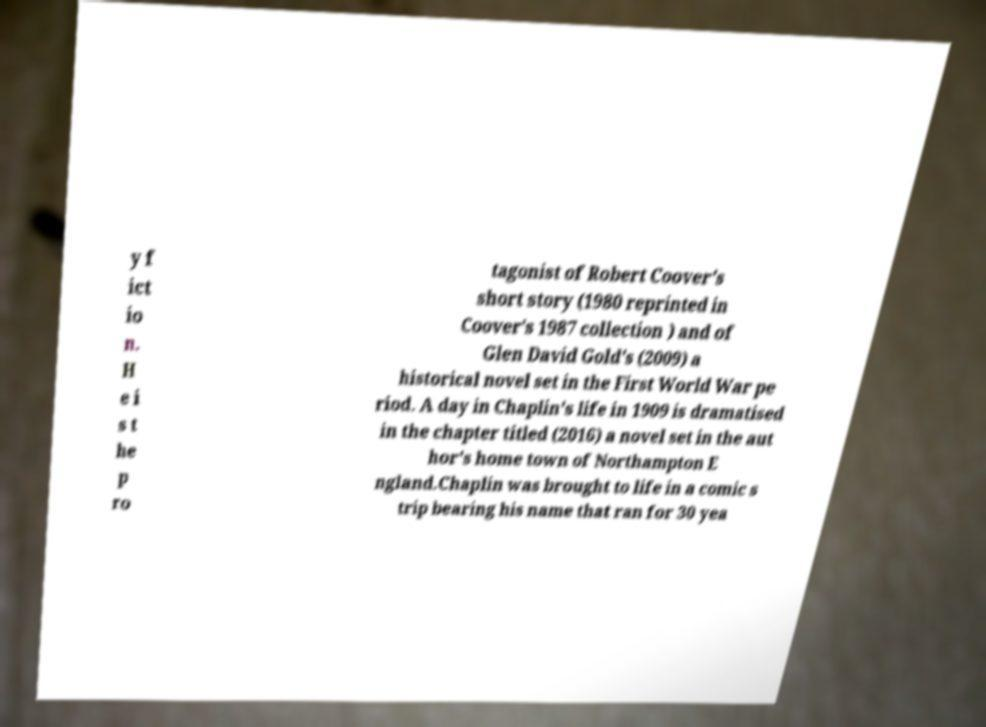I need the written content from this picture converted into text. Can you do that? y f ict io n. H e i s t he p ro tagonist of Robert Coover's short story (1980 reprinted in Coover's 1987 collection ) and of Glen David Gold's (2009) a historical novel set in the First World War pe riod. A day in Chaplin's life in 1909 is dramatised in the chapter titled (2016) a novel set in the aut hor's home town of Northampton E ngland.Chaplin was brought to life in a comic s trip bearing his name that ran for 30 yea 